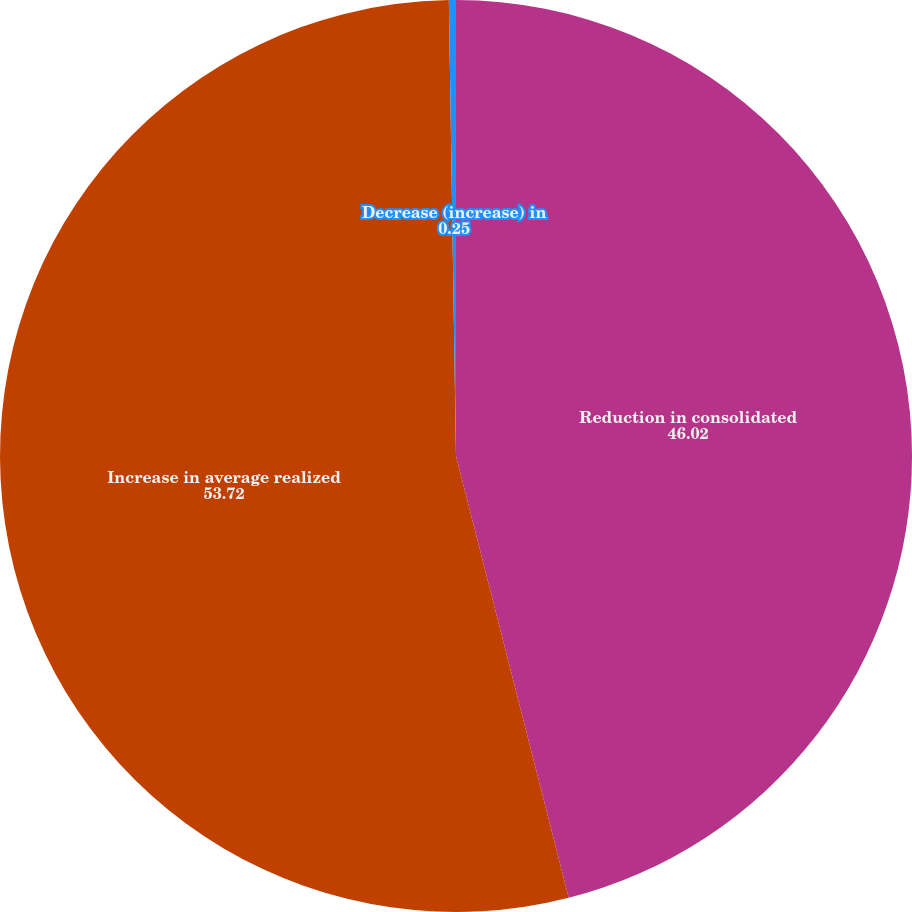Convert chart to OTSL. <chart><loc_0><loc_0><loc_500><loc_500><pie_chart><fcel>Reduction in consolidated<fcel>Increase in average realized<fcel>Decrease (increase) in<nl><fcel>46.02%<fcel>53.72%<fcel>0.25%<nl></chart> 